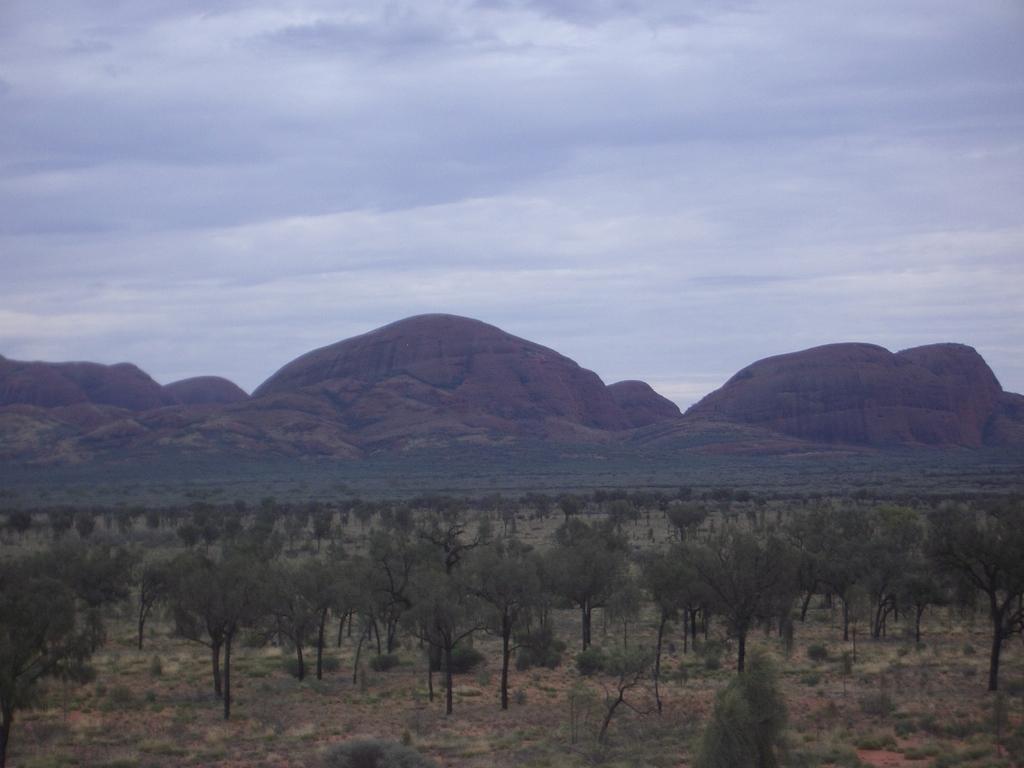Describe this image in one or two sentences. In this picture there are mountains and trees. At the top there is sky and there are clouds. At the bottom there is mud. 